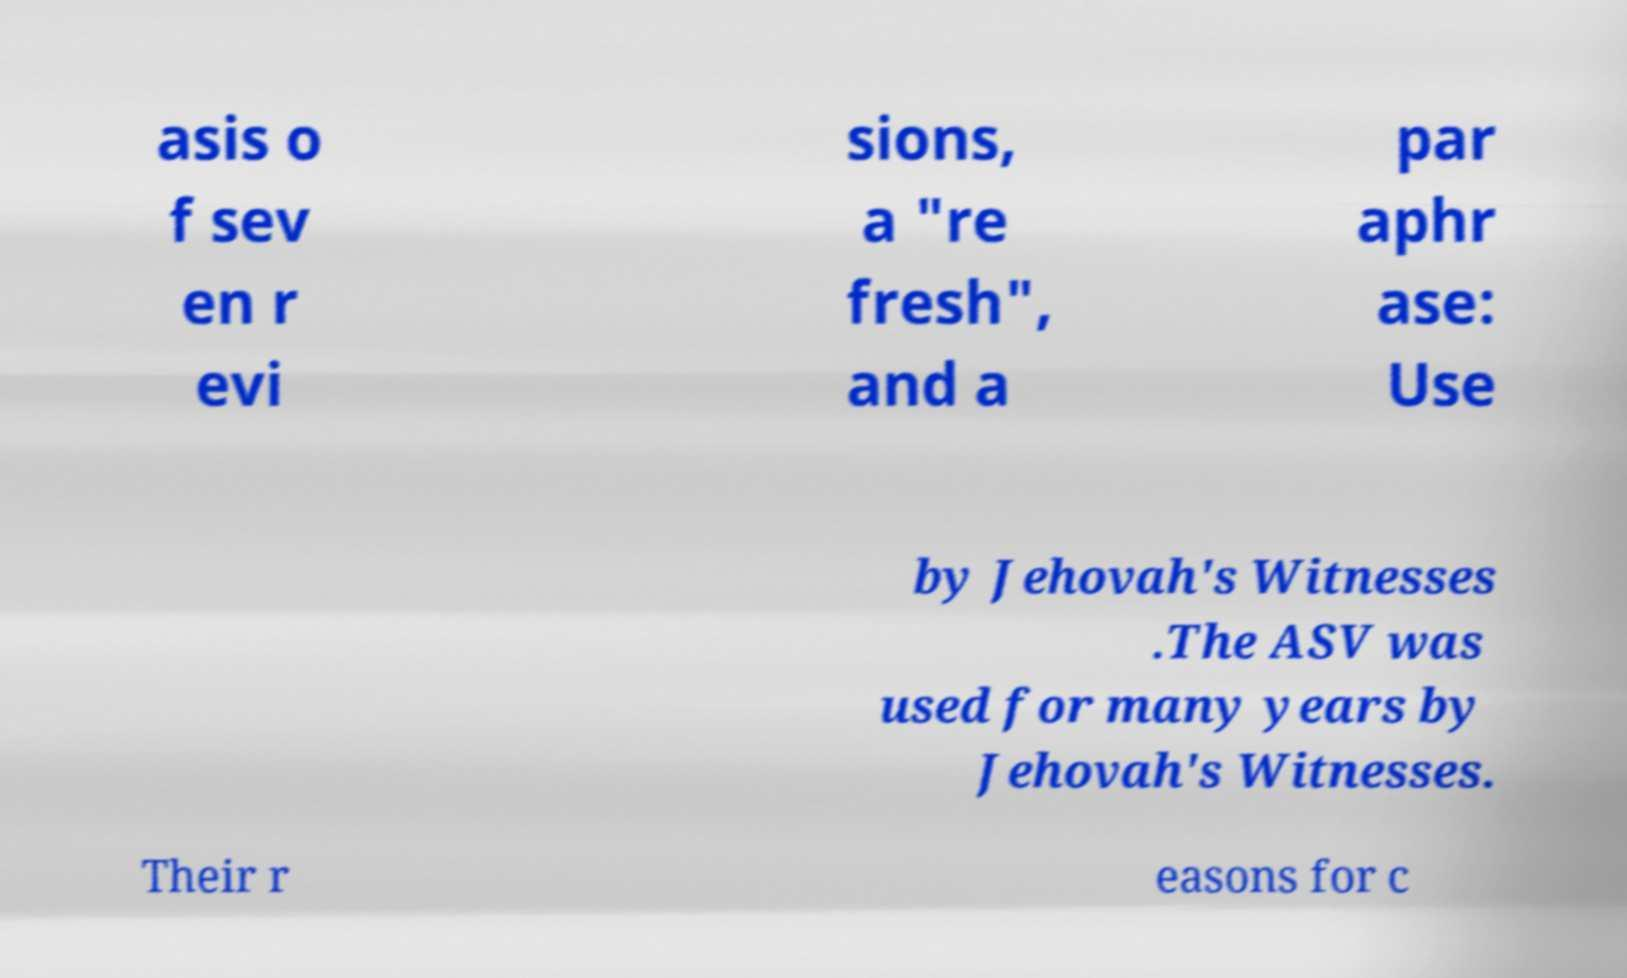I need the written content from this picture converted into text. Can you do that? asis o f sev en r evi sions, a "re fresh", and a par aphr ase: Use by Jehovah's Witnesses .The ASV was used for many years by Jehovah's Witnesses. Their r easons for c 